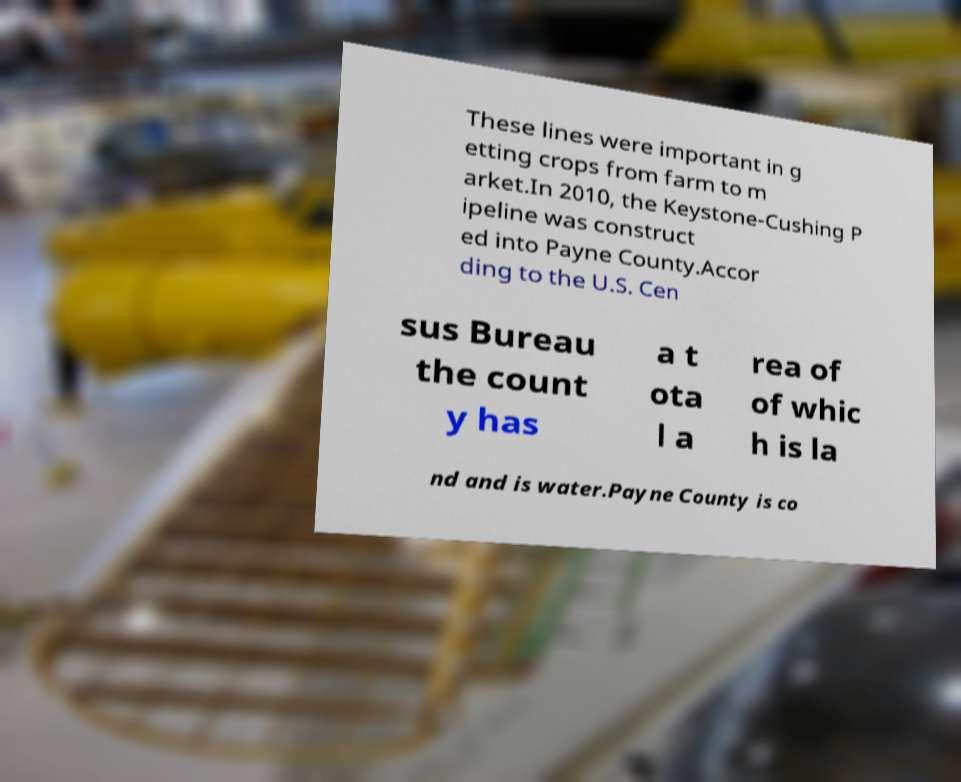I need the written content from this picture converted into text. Can you do that? These lines were important in g etting crops from farm to m arket.In 2010, the Keystone-Cushing P ipeline was construct ed into Payne County.Accor ding to the U.S. Cen sus Bureau the count y has a t ota l a rea of of whic h is la nd and is water.Payne County is co 